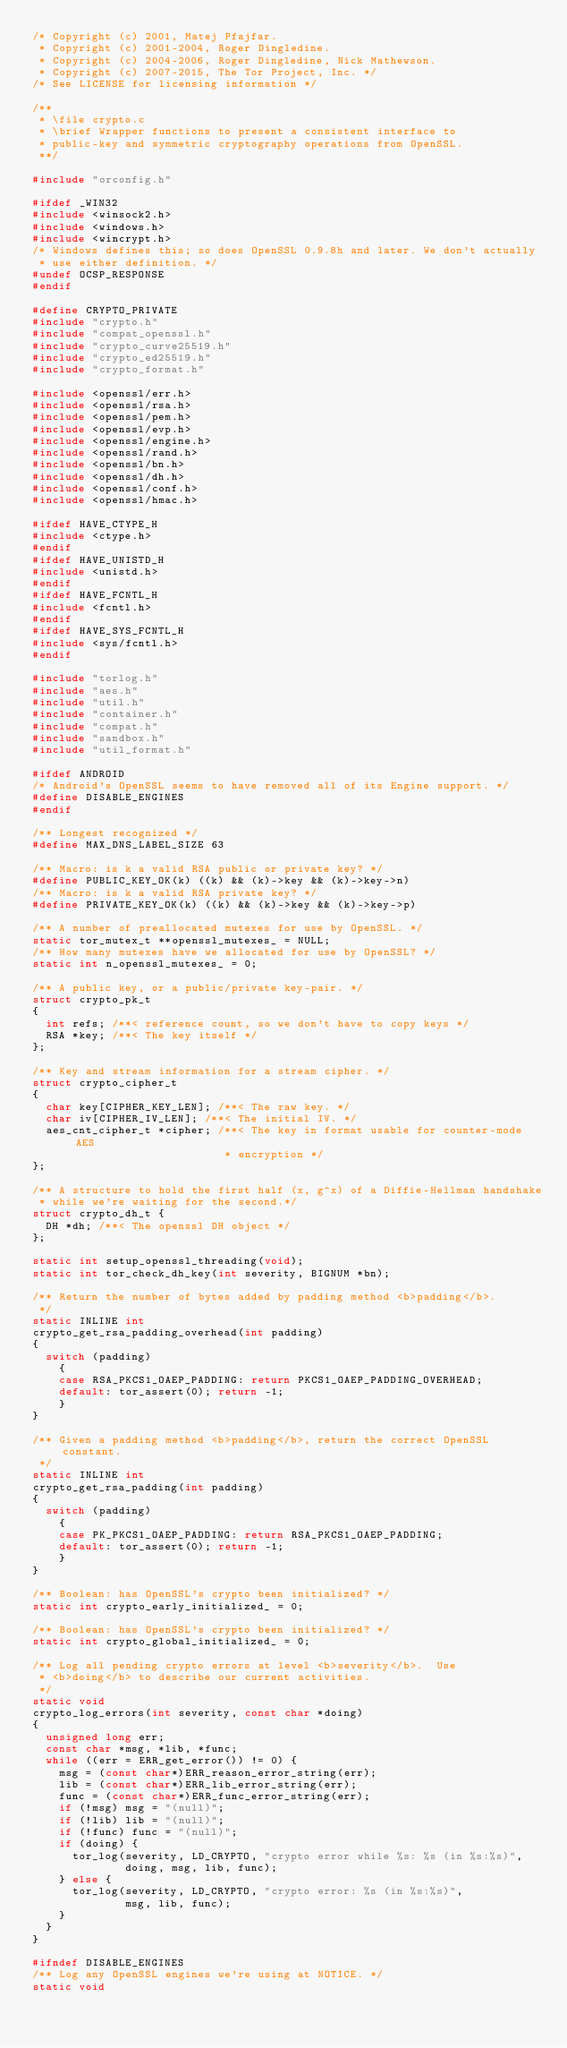Convert code to text. <code><loc_0><loc_0><loc_500><loc_500><_C_>/* Copyright (c) 2001, Matej Pfajfar.
 * Copyright (c) 2001-2004, Roger Dingledine.
 * Copyright (c) 2004-2006, Roger Dingledine, Nick Mathewson.
 * Copyright (c) 2007-2015, The Tor Project, Inc. */
/* See LICENSE for licensing information */

/**
 * \file crypto.c
 * \brief Wrapper functions to present a consistent interface to
 * public-key and symmetric cryptography operations from OpenSSL.
 **/

#include "orconfig.h"

#ifdef _WIN32
#include <winsock2.h>
#include <windows.h>
#include <wincrypt.h>
/* Windows defines this; so does OpenSSL 0.9.8h and later. We don't actually
 * use either definition. */
#undef OCSP_RESPONSE
#endif

#define CRYPTO_PRIVATE
#include "crypto.h"
#include "compat_openssl.h"
#include "crypto_curve25519.h"
#include "crypto_ed25519.h"
#include "crypto_format.h"

#include <openssl/err.h>
#include <openssl/rsa.h>
#include <openssl/pem.h>
#include <openssl/evp.h>
#include <openssl/engine.h>
#include <openssl/rand.h>
#include <openssl/bn.h>
#include <openssl/dh.h>
#include <openssl/conf.h>
#include <openssl/hmac.h>

#ifdef HAVE_CTYPE_H
#include <ctype.h>
#endif
#ifdef HAVE_UNISTD_H
#include <unistd.h>
#endif
#ifdef HAVE_FCNTL_H
#include <fcntl.h>
#endif
#ifdef HAVE_SYS_FCNTL_H
#include <sys/fcntl.h>
#endif

#include "torlog.h"
#include "aes.h"
#include "util.h"
#include "container.h"
#include "compat.h"
#include "sandbox.h"
#include "util_format.h"

#ifdef ANDROID
/* Android's OpenSSL seems to have removed all of its Engine support. */
#define DISABLE_ENGINES
#endif

/** Longest recognized */
#define MAX_DNS_LABEL_SIZE 63

/** Macro: is k a valid RSA public or private key? */
#define PUBLIC_KEY_OK(k) ((k) && (k)->key && (k)->key->n)
/** Macro: is k a valid RSA private key? */
#define PRIVATE_KEY_OK(k) ((k) && (k)->key && (k)->key->p)

/** A number of preallocated mutexes for use by OpenSSL. */
static tor_mutex_t **openssl_mutexes_ = NULL;
/** How many mutexes have we allocated for use by OpenSSL? */
static int n_openssl_mutexes_ = 0;

/** A public key, or a public/private key-pair. */
struct crypto_pk_t
{
  int refs; /**< reference count, so we don't have to copy keys */
  RSA *key; /**< The key itself */
};

/** Key and stream information for a stream cipher. */
struct crypto_cipher_t
{
  char key[CIPHER_KEY_LEN]; /**< The raw key. */
  char iv[CIPHER_IV_LEN]; /**< The initial IV. */
  aes_cnt_cipher_t *cipher; /**< The key in format usable for counter-mode AES
                             * encryption */
};

/** A structure to hold the first half (x, g^x) of a Diffie-Hellman handshake
 * while we're waiting for the second.*/
struct crypto_dh_t {
  DH *dh; /**< The openssl DH object */
};

static int setup_openssl_threading(void);
static int tor_check_dh_key(int severity, BIGNUM *bn);

/** Return the number of bytes added by padding method <b>padding</b>.
 */
static INLINE int
crypto_get_rsa_padding_overhead(int padding)
{
  switch (padding)
    {
    case RSA_PKCS1_OAEP_PADDING: return PKCS1_OAEP_PADDING_OVERHEAD;
    default: tor_assert(0); return -1;
    }
}

/** Given a padding method <b>padding</b>, return the correct OpenSSL constant.
 */
static INLINE int
crypto_get_rsa_padding(int padding)
{
  switch (padding)
    {
    case PK_PKCS1_OAEP_PADDING: return RSA_PKCS1_OAEP_PADDING;
    default: tor_assert(0); return -1;
    }
}

/** Boolean: has OpenSSL's crypto been initialized? */
static int crypto_early_initialized_ = 0;

/** Boolean: has OpenSSL's crypto been initialized? */
static int crypto_global_initialized_ = 0;

/** Log all pending crypto errors at level <b>severity</b>.  Use
 * <b>doing</b> to describe our current activities.
 */
static void
crypto_log_errors(int severity, const char *doing)
{
  unsigned long err;
  const char *msg, *lib, *func;
  while ((err = ERR_get_error()) != 0) {
    msg = (const char*)ERR_reason_error_string(err);
    lib = (const char*)ERR_lib_error_string(err);
    func = (const char*)ERR_func_error_string(err);
    if (!msg) msg = "(null)";
    if (!lib) lib = "(null)";
    if (!func) func = "(null)";
    if (doing) {
      tor_log(severity, LD_CRYPTO, "crypto error while %s: %s (in %s:%s)",
              doing, msg, lib, func);
    } else {
      tor_log(severity, LD_CRYPTO, "crypto error: %s (in %s:%s)",
              msg, lib, func);
    }
  }
}

#ifndef DISABLE_ENGINES
/** Log any OpenSSL engines we're using at NOTICE. */
static void</code> 